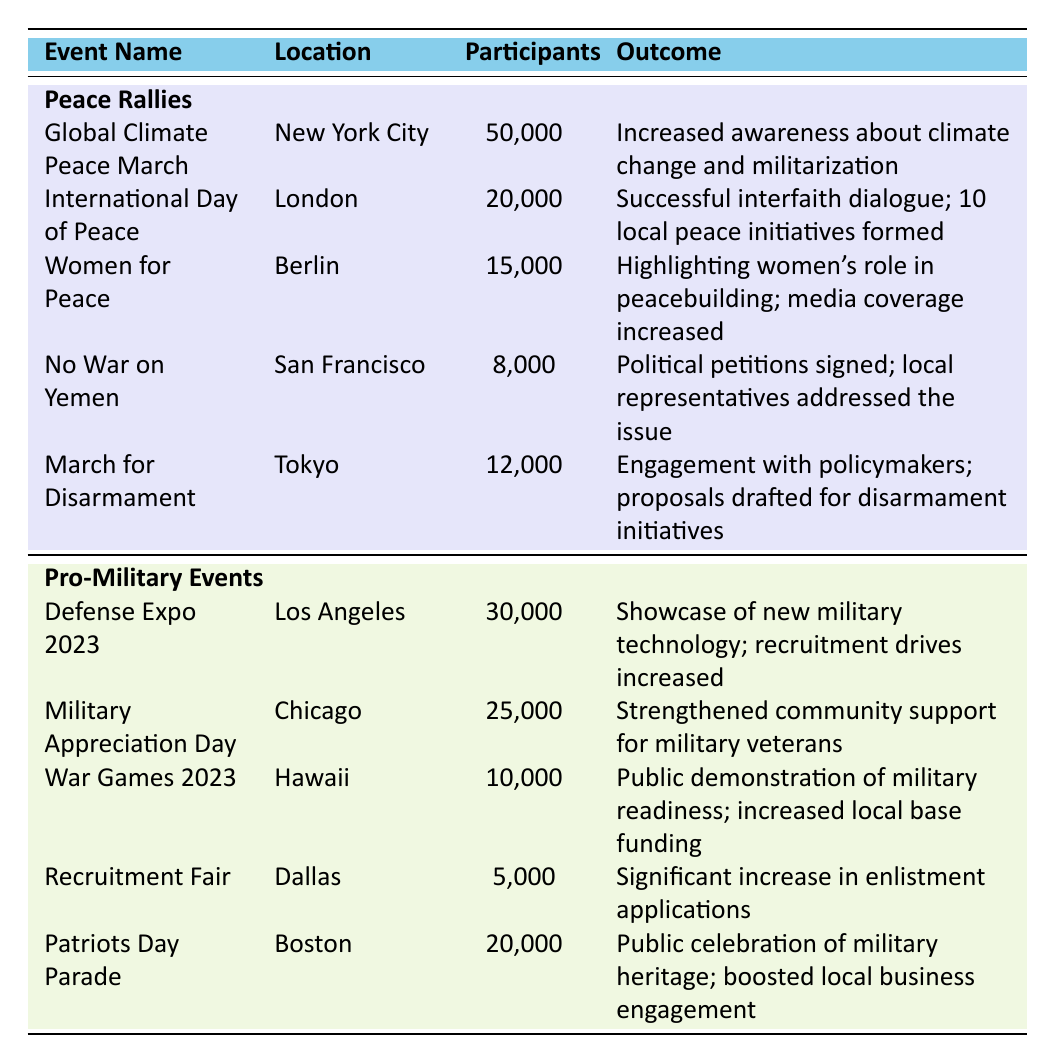What is the total number of participants in the peace rallies? To find the total participants in peace rallies, we add the participants from all five events: 50,000 + 20,000 + 15,000 + 8,000 + 12,000 = 105,000.
Answer: 105,000 Which event had the highest number of participants among pro-military events? By examining the pro-military events, the Defense Expo 2023 has the highest number of participants at 30,000.
Answer: Defense Expo 2023 How many peace rallies had more than 10,000 participants? Reviewing the table, three peace rallies exceeded 10,000 participants: the Global Climate Peace March (50,000), International Day of Peace (20,000), and Women for Peace (15,000).
Answer: 3 Did the Women for Peace event have a positive outcome related to media? Yes, the Women for Peace event highlighted women's role in peacebuilding and mentioned an increase in media coverage as a positive outcome.
Answer: Yes Which group had a total of 60,000 participants, peace rallies or pro-military events? The peace rallies had 105,000 total participants and the pro-military events had 65,000 (30,000 + 25,000 + 10,000 + 5,000 + 20,000). Since neither equals 60,000, the answer is neither.
Answer: Neither What is the average number of participants in the peace rallies? To find the average, sum the participants (105,000) and divide by the number of events (5). So, 105,000 / 5 = 21,000.
Answer: 21,000 Which city hosted the event focused on interfaith dialogue? The International Day of Peace took place in London and was focused on successful interfaith dialogue.
Answer: London Was the outcome of the March for Disarmament related to proposals? Yes, the outcome highlighted engagement with policymakers and the drafting of proposals for disarmament initiatives.
Answer: Yes How many more participants did the Military Appreciation Day have compared to the No War on Yemen event? Military Appreciation Day had 25,000 participants, while No War on Yemen had 8,000 participants. The difference is 25,000 - 8,000 = 17,000.
Answer: 17,000 Which event saw the lowest participation among both categories? The Recruitment Fair had the lowest participation with only 5,000 participants among pro-military events, which is less than any peace rally.
Answer: Recruitment Fair 